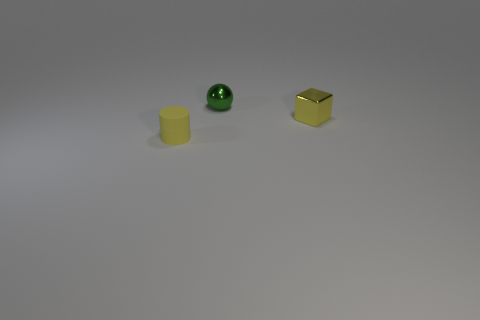Add 1 tiny matte cylinders. How many objects exist? 4 Subtract all cubes. How many objects are left? 2 Subtract all big things. Subtract all small metallic spheres. How many objects are left? 2 Add 1 tiny shiny things. How many tiny shiny things are left? 3 Add 2 small gray matte cubes. How many small gray matte cubes exist? 2 Subtract 0 red balls. How many objects are left? 3 